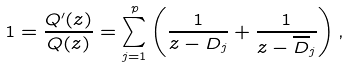Convert formula to latex. <formula><loc_0><loc_0><loc_500><loc_500>1 = \frac { Q ^ { \prime } ( z ) } { Q ( z ) } = \sum _ { j = 1 } ^ { p } \left ( \frac { 1 } { z - D _ { j } } + \frac { 1 } { z - \overline { D } _ { j } } \right ) ,</formula> 